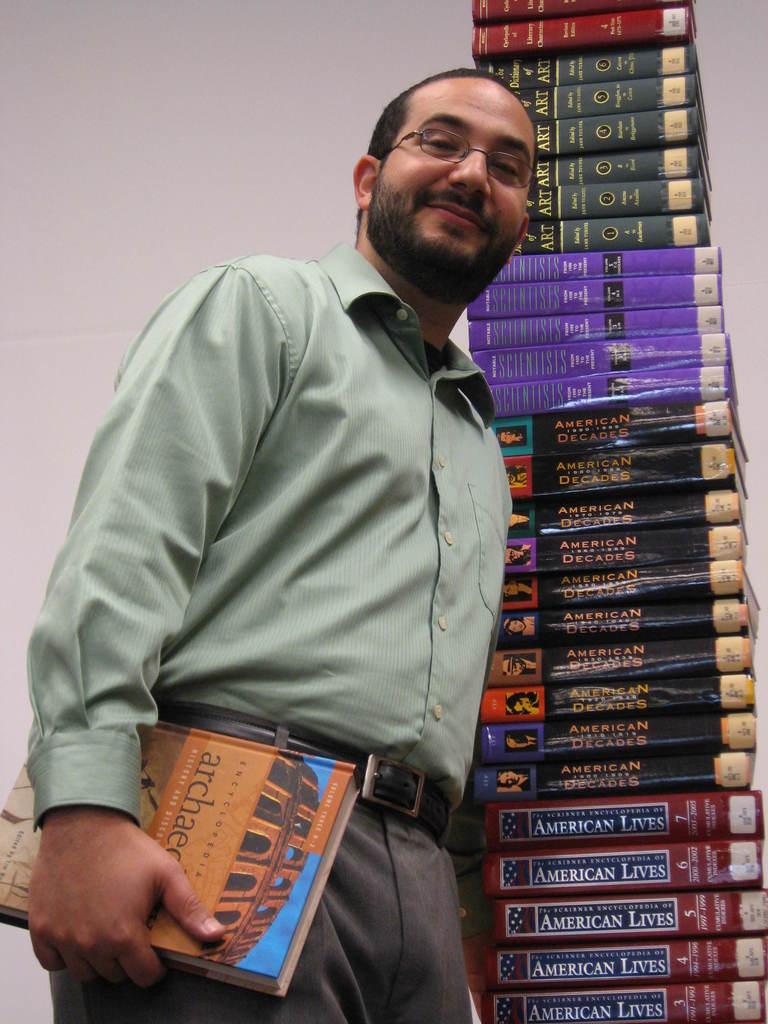What kind of lives do the books on the bottom on the pile talk about?
Offer a very short reply. American. What is the subject of the book the man is holding?
Your answer should be very brief. Archaeology. 